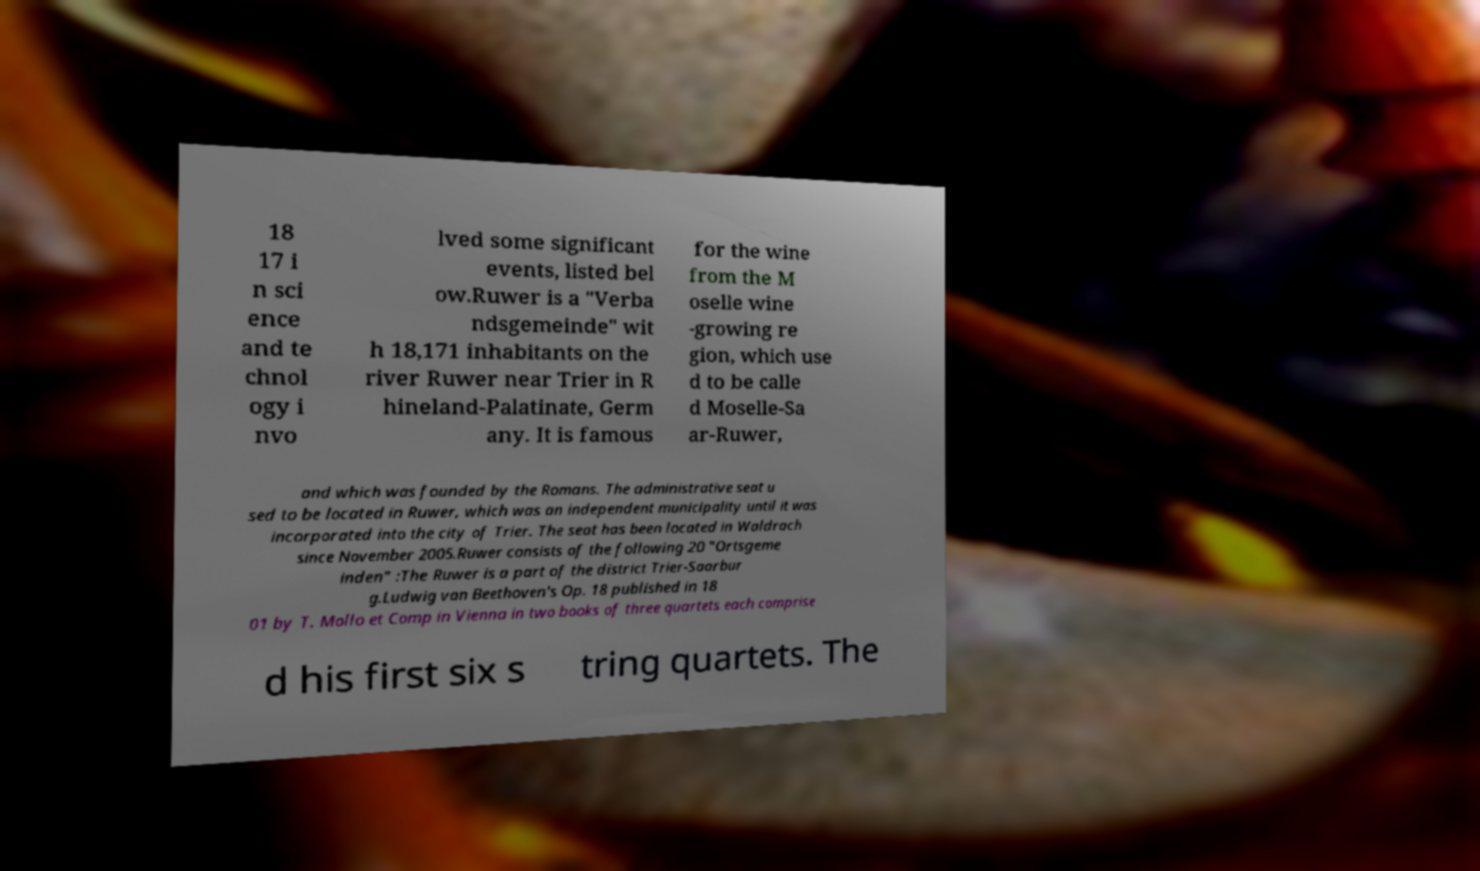For documentation purposes, I need the text within this image transcribed. Could you provide that? 18 17 i n sci ence and te chnol ogy i nvo lved some significant events, listed bel ow.Ruwer is a "Verba ndsgemeinde" wit h 18,171 inhabitants on the river Ruwer near Trier in R hineland-Palatinate, Germ any. It is famous for the wine from the M oselle wine -growing re gion, which use d to be calle d Moselle-Sa ar-Ruwer, and which was founded by the Romans. The administrative seat u sed to be located in Ruwer, which was an independent municipality until it was incorporated into the city of Trier. The seat has been located in Waldrach since November 2005.Ruwer consists of the following 20 "Ortsgeme inden" :The Ruwer is a part of the district Trier-Saarbur g.Ludwig van Beethoven's Op. 18 published in 18 01 by T. Mollo et Comp in Vienna in two books of three quartets each comprise d his first six s tring quartets. The 